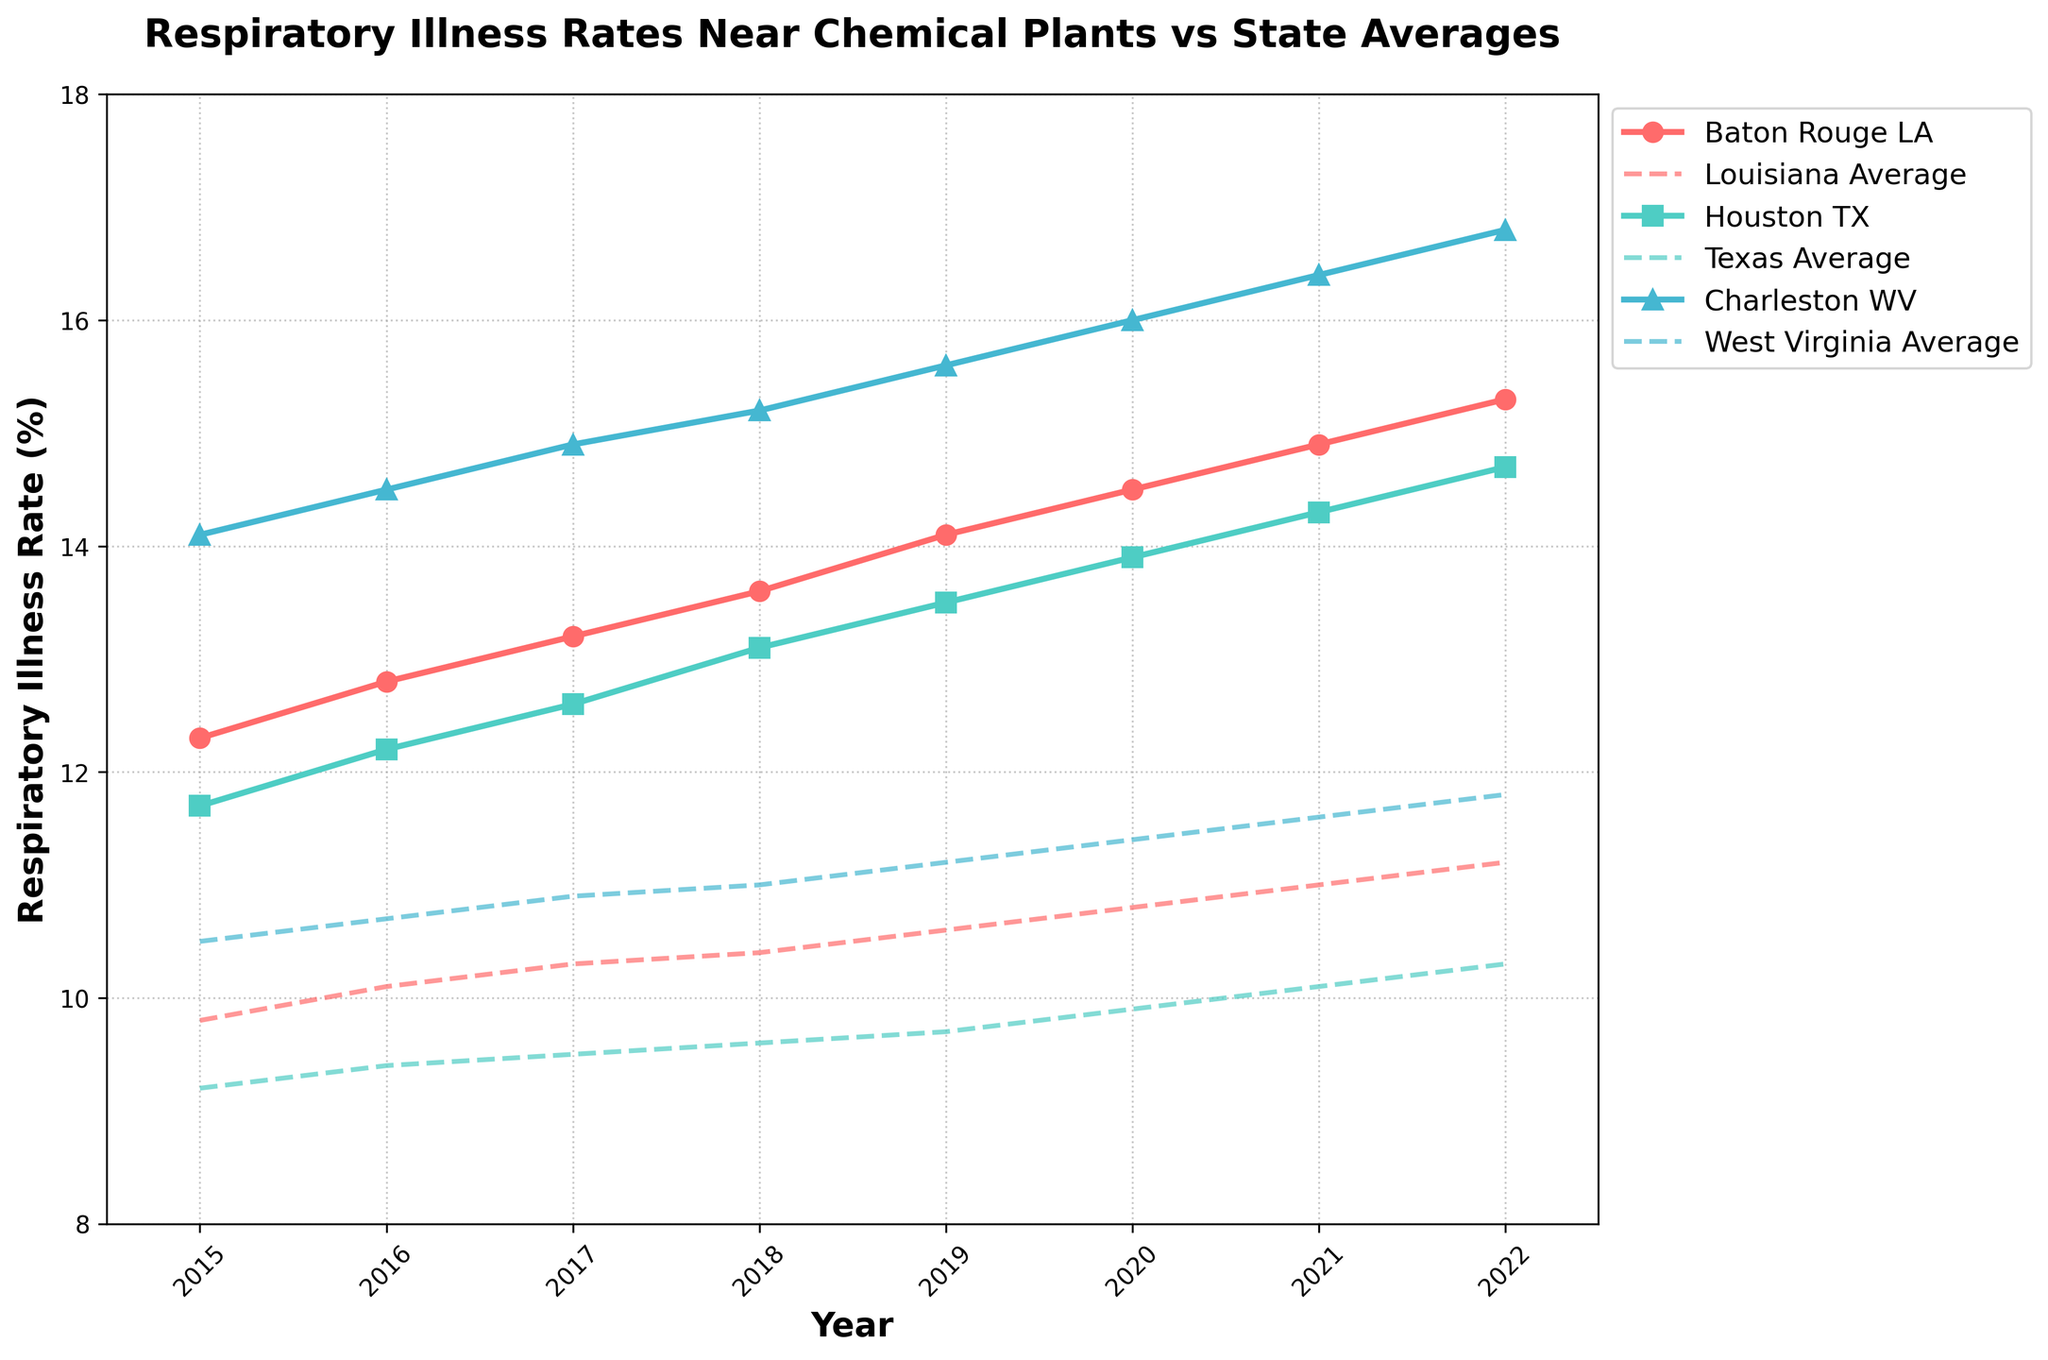What is the highest respiratory illness rate recorded in Baton Rouge, LA over the years 2015 to 2022? The line for Baton Rouge, LA shows the respiratory illness rate increasing steadily over the years. The highest value on the graph for Baton Rouge, LA appears in 2022.
Answer: 15.3 Is the respiratory illness rate in Houston, TX higher or lower than the Texas state average in 2020? Observing the year 2020, the line for Houston, TX is plotted above the line for the Texas average. This indicates that the rate in Houston is higher than the state average.
Answer: Higher What is the difference in respiratory illness rates between Charleston, WV, and the West Virginia state average in 2019? In 2019, the rate for Charleston, WV is plotted at 15.6% and the West Virginia average is at 11.2%. The difference is calculated as 15.6 - 11.2.
Answer: 4.4 Between 2015 and 2022, which year saw the largest gap between Baton Rouge, LA and the Louisiana state average? Examining the plotted lines, the largest gap appears in 2022 when the rate for Baton Rouge, LA is 15.3% and the Louisiana state average is 11.2%. Calculating the difference: 15.3 - 11.2.
Answer: 2022 How much did the respiratory illness rate in Houston, TX increase from 2017 to 2022? The rate for Houston, TX in 2017 is 12.6% and in 2022 it is 14.7%. The increase is calculated as 14.7 - 12.6.
Answer: 2.1 What trend do you observe in the respiratory illness rates in Charleston, WV, from 2015 to 2022? The line for Charleston, WV shows a steady upward trend from 14.1% in 2015 to 16.8% in 2022, indicating a consistent increase over the years.
Answer: Steady increase Which community consistently has a higher respiratory illness rate compared to its state average from 2015 to 2022? Both Baton Rouge, LA, Houston, TX, and Charleston, WV are compared to their state averages across the years. Charleston, WV consistently shows a higher rate than the West Virginia state average.
Answer: Charleston, WV What can you infer about the overall difference in respiratory illness rates between communities near chemical plants and their respective state averages? All three communities (Baton Rouge, LA; Houston, TX; Charleston, WV) have consistently higher respiratory illness rates than their respective state averages throughout the observed years. This suggests a potential correlation between proximity to chemical plants and higher respiratory illness rates.
Answer: Higher near chemical plants 